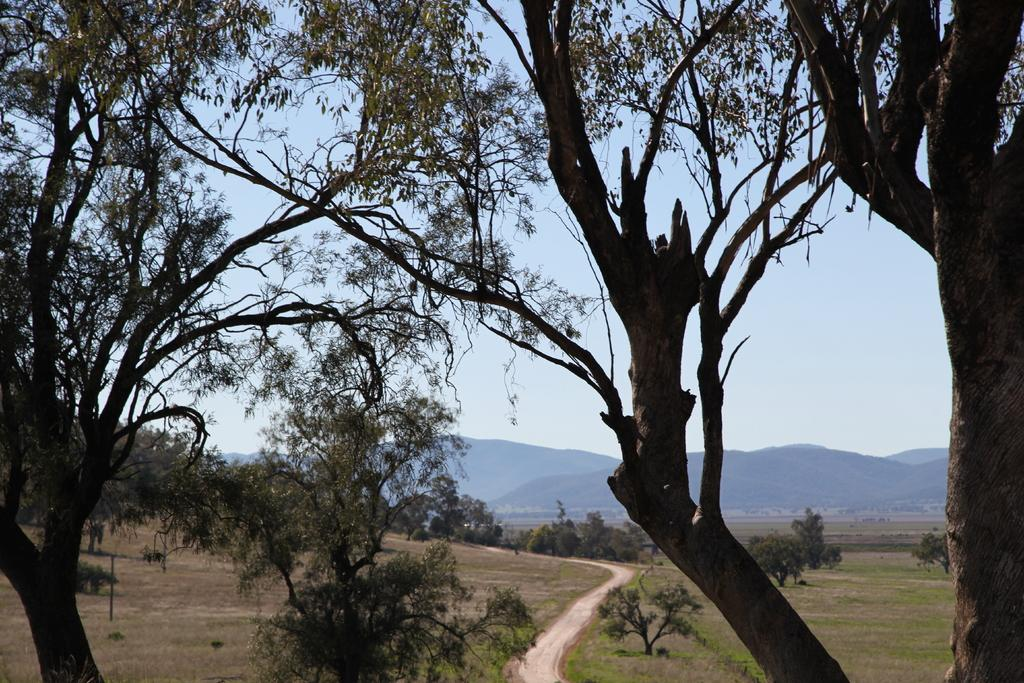What type of vegetation can be seen in the image? There are trees in the image. What is present at the bottom of the image? There is grass at the bottom of the image. What part of the natural environment is visible in the image? The sky is visible at the top of the image. What memory is being triggered by the trees in the image? There is no indication in the image that any memories are being triggered by the trees. What type of thing is being used to measure the height of the trees in the image? There is no measuring device or any indication of measuring the height of the trees in the image. 